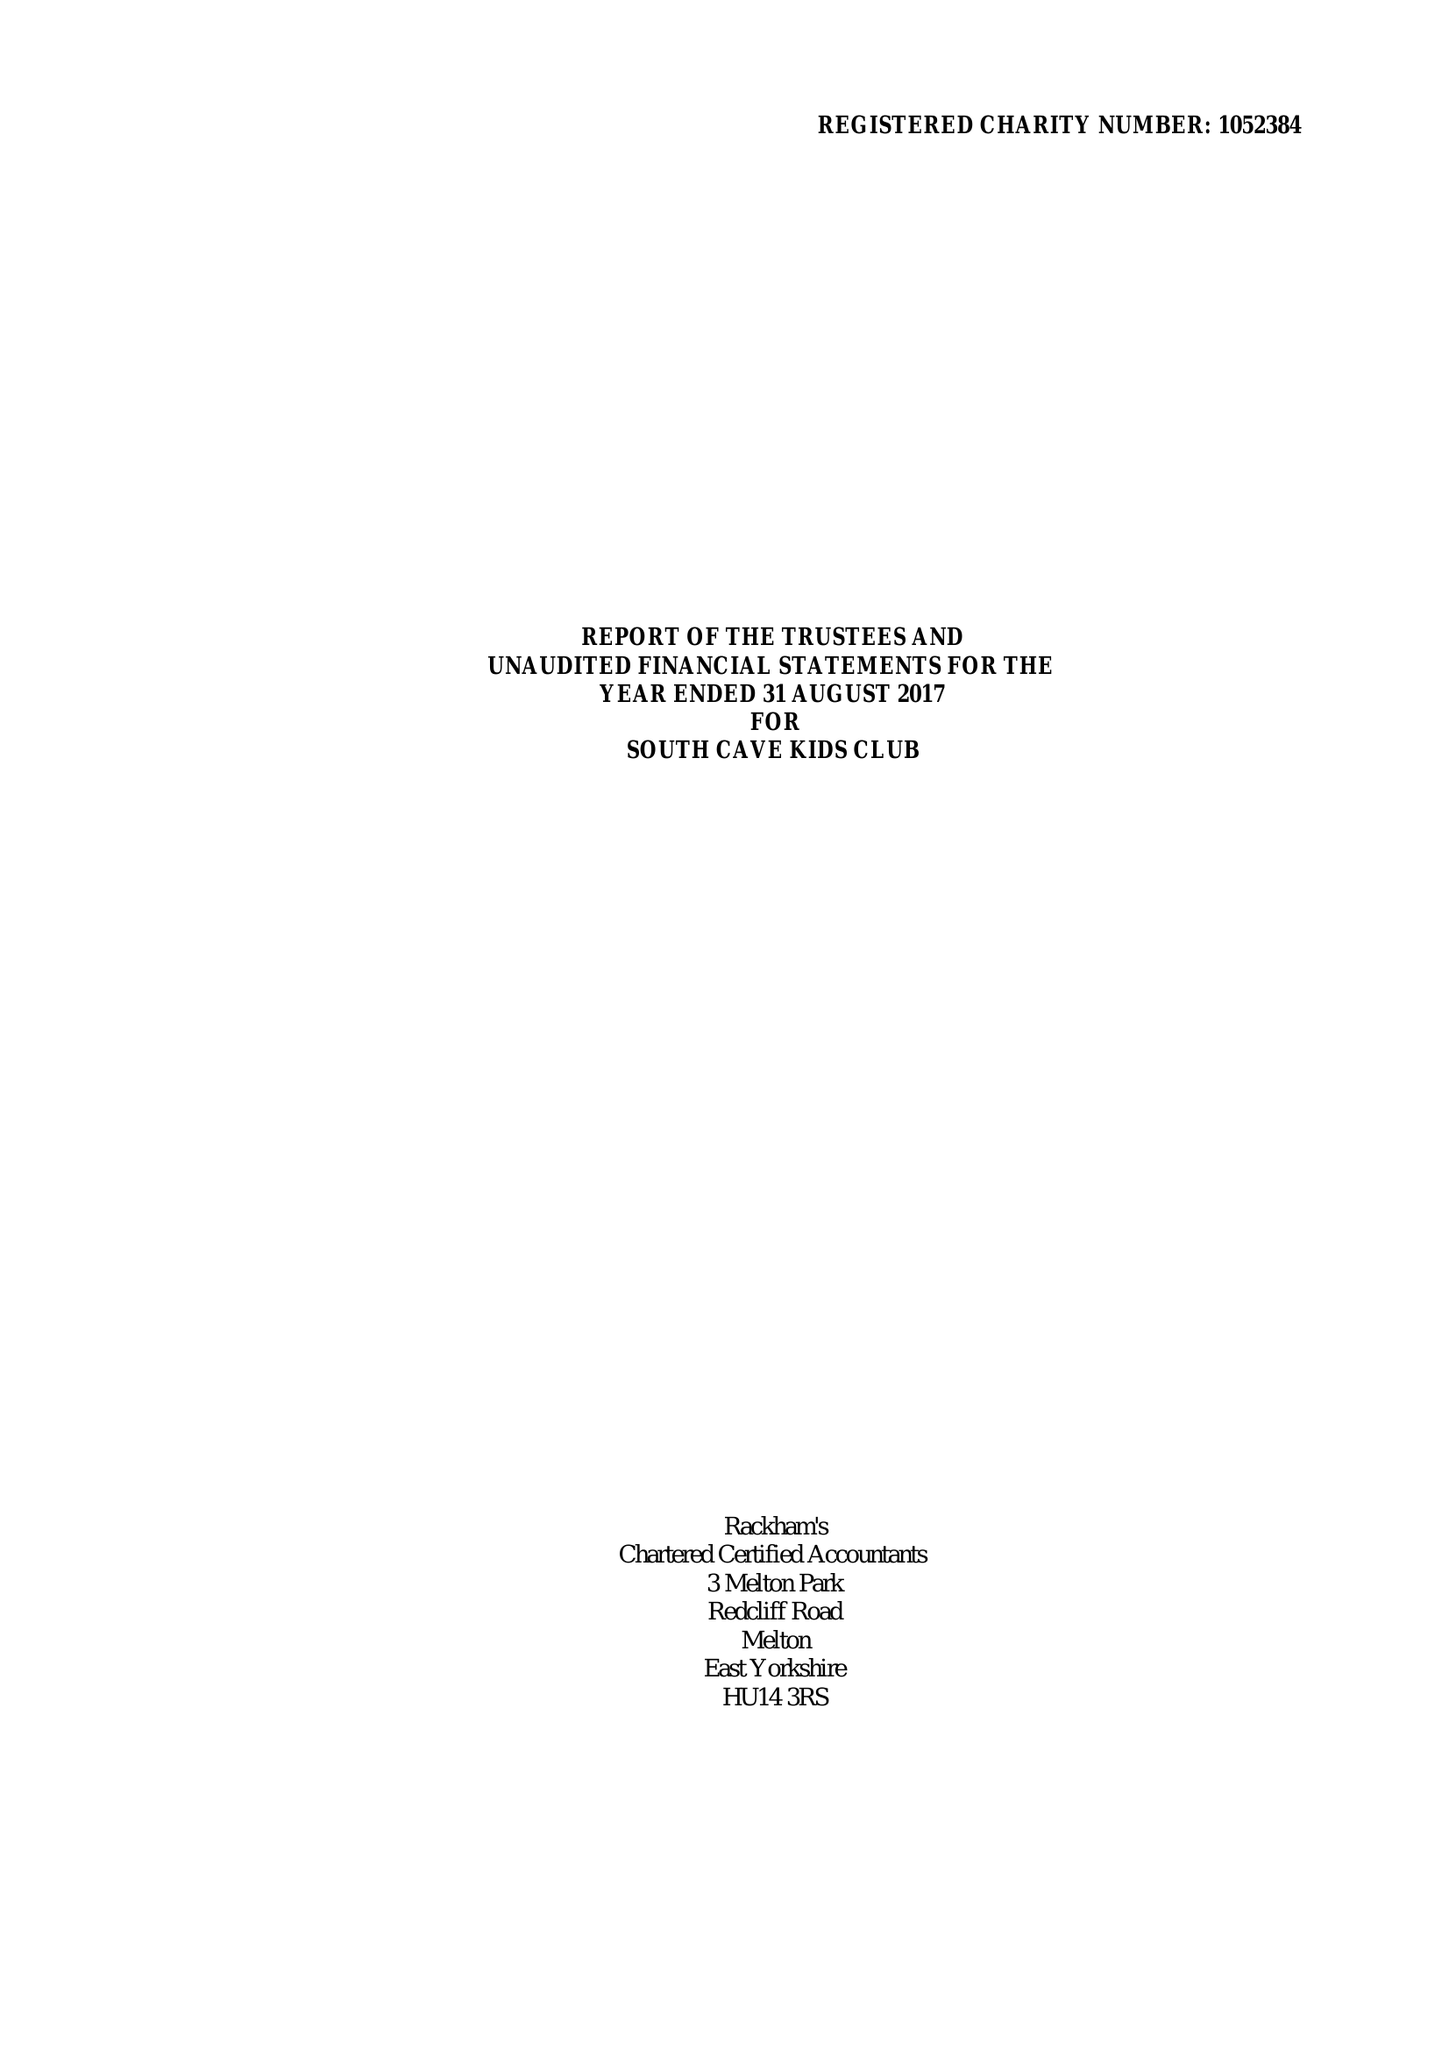What is the value for the charity_name?
Answer the question using a single word or phrase. South Cave Kids Club 